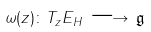Convert formula to latex. <formula><loc_0><loc_0><loc_500><loc_500>\omega ( z ) \colon T _ { z } E _ { H } \, \longrightarrow \, { \mathfrak g }</formula> 